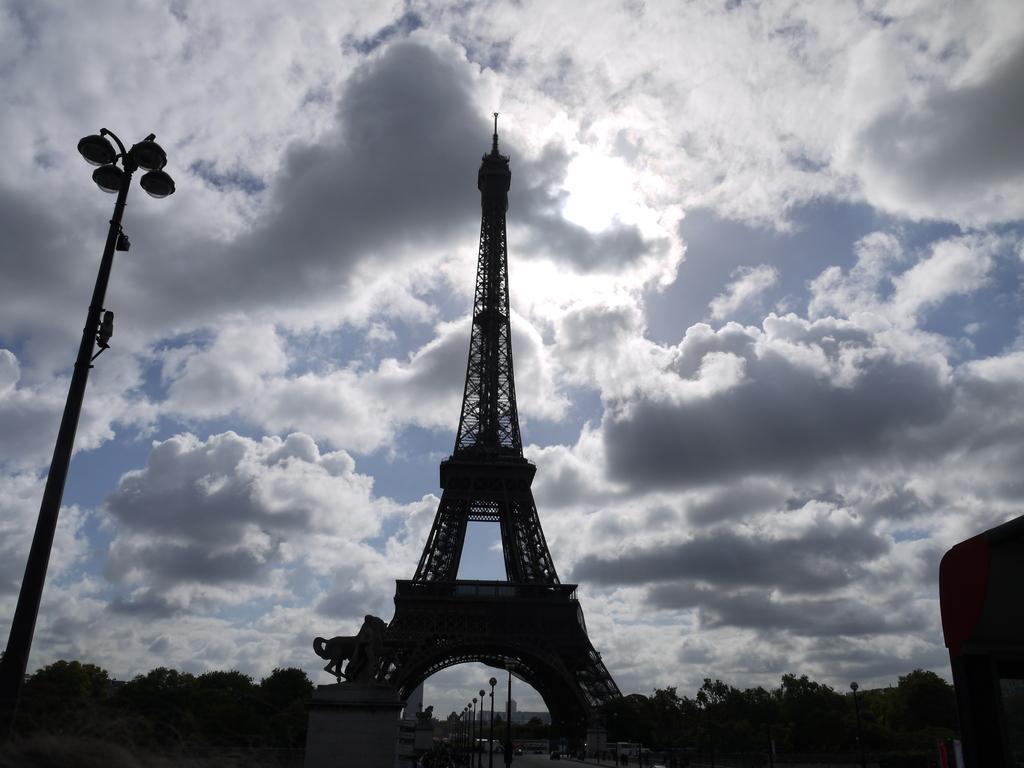In one or two sentences, can you explain what this image depicts? At the bottom the image is dark but we can see trees, poles, vehicles on the road and in the middle there is a Eiffel tower and on the left side there is a light pole. In the background we can see clouds in the sky. 